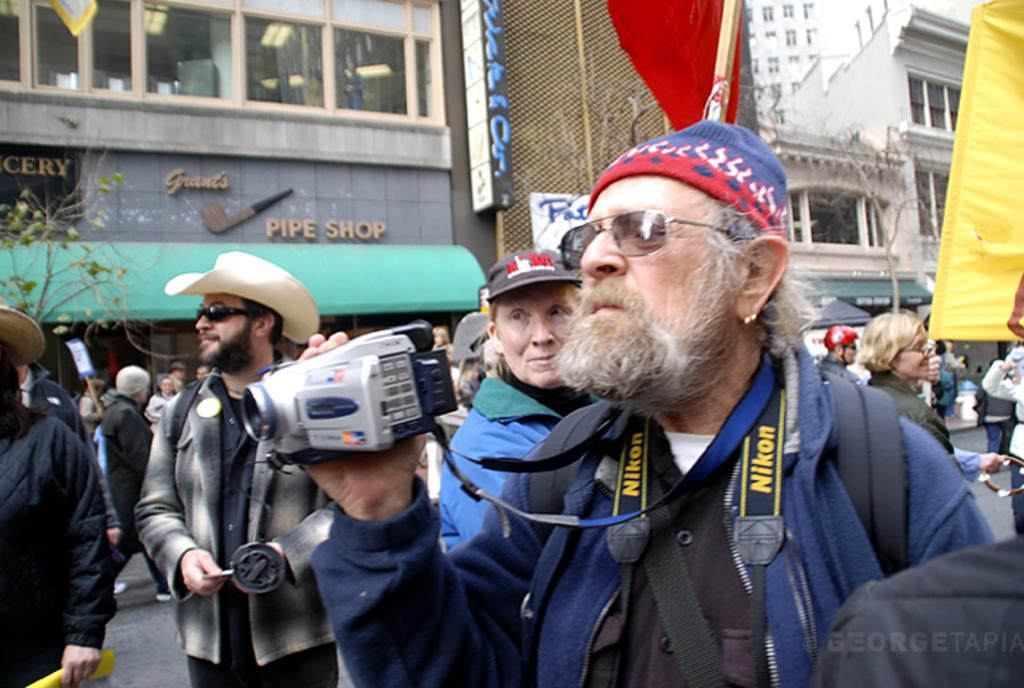What is happening on the road in the image? There are persons on the road in the image. What is one person doing in the image? One person is holding a camera with their hand. Can you describe the person holding the camera? The person holding the camera is wearing spectacles. What can be seen in the background of the image? There is a building in the background of the image. What type of vegetation is present in the image? There is a tree in the image. What type of square can be seen in the image? There is no square present in the image. Is there a boy visible in the image? The provided facts do not mention a boy, so it cannot be determined if a boy is present in the image. 